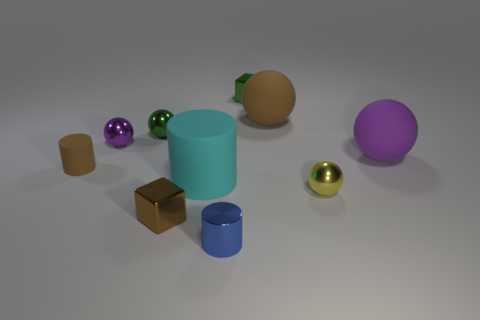Subtract all green balls. How many balls are left? 4 Subtract all yellow shiny balls. How many balls are left? 4 Subtract all cyan cylinders. Subtract all gray cubes. How many cylinders are left? 2 Subtract all cylinders. How many objects are left? 7 Add 6 big green rubber cylinders. How many big green rubber cylinders exist? 6 Subtract 1 green blocks. How many objects are left? 9 Subtract all big cyan cylinders. Subtract all green shiny cubes. How many objects are left? 8 Add 2 cyan rubber cylinders. How many cyan rubber cylinders are left? 3 